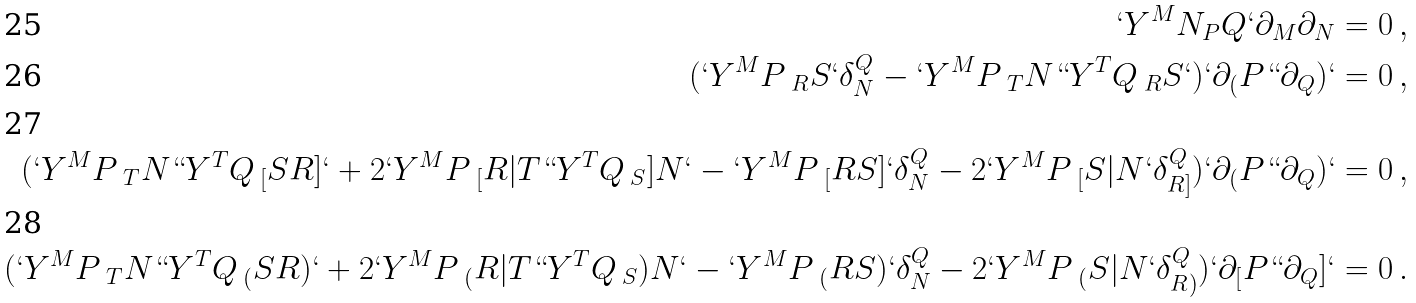<formula> <loc_0><loc_0><loc_500><loc_500>` Y ^ { M } N _ { P } Q ` \partial _ { M } \partial _ { N } = 0 \, , \\ ( ` Y ^ { M } P \, _ { R } S ` \delta _ { N } ^ { Q } - ` Y ^ { M } P \, _ { T } N ` ` Y ^ { T } Q \, _ { R } S ` ) ` \partial _ { ( } P ` ` \partial _ { Q } ) ` = 0 \, , \\ ( ` Y ^ { M } P \, _ { T } N ` ` Y ^ { T } Q \, _ { [ } S R ] ` + 2 ` Y ^ { M } P \, _ { [ } R | T ` ` Y ^ { T } Q \, _ { S } ] N ` - ` Y ^ { M } P \, _ { [ } R S ] ` \delta ^ { Q } _ { N } - 2 ` Y ^ { M } P \, _ { [ } S | N ` \delta _ { R ] } ^ { Q } ) ` \partial _ { ( } P ` ` \partial _ { Q } ) ` = 0 \, , \\ ( ` Y ^ { M } P \, _ { T } N ` ` Y ^ { T } Q \, _ { ( } S R ) ` + 2 ` Y ^ { M } P \, _ { ( } R | T ` ` Y ^ { T } Q \, _ { S } ) N ` - ` Y ^ { M } P \, _ { ( } R S ) ` \delta ^ { Q } _ { N } - 2 ` Y ^ { M } P \, _ { ( } S | N ` \delta _ { R ) } ^ { Q } ) ` \partial _ { [ } P ` ` \partial _ { Q } ] ` = 0 \, .</formula> 